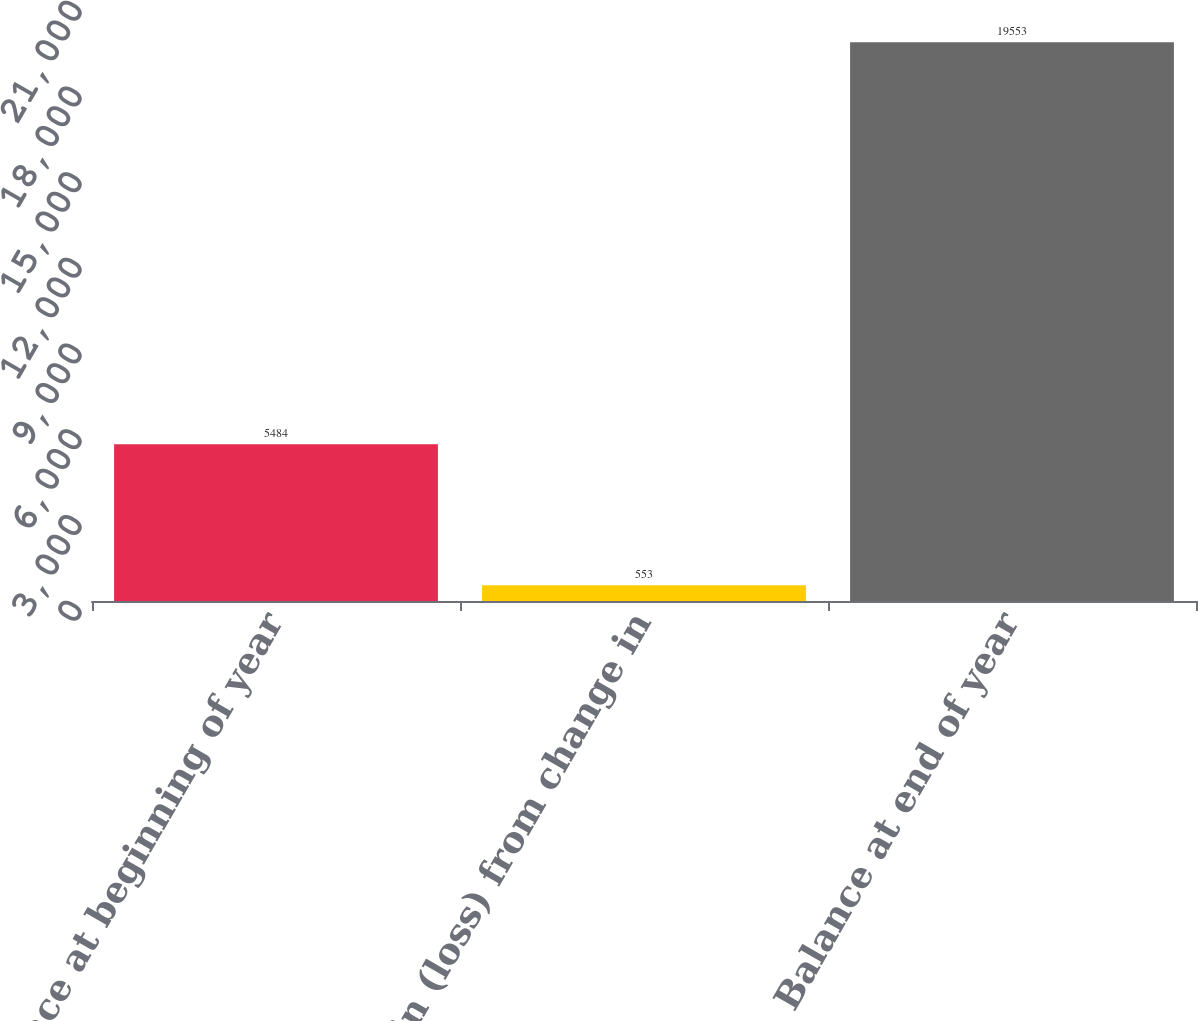Convert chart to OTSL. <chart><loc_0><loc_0><loc_500><loc_500><bar_chart><fcel>Balance at beginning of year<fcel>Net gain (loss) from change in<fcel>Balance at end of year<nl><fcel>5484<fcel>553<fcel>19553<nl></chart> 